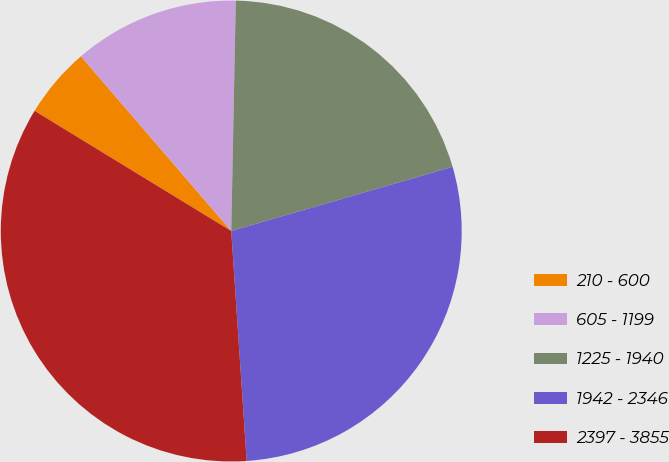<chart> <loc_0><loc_0><loc_500><loc_500><pie_chart><fcel>210 - 600<fcel>605 - 1199<fcel>1225 - 1940<fcel>1942 - 2346<fcel>2397 - 3855<nl><fcel>4.96%<fcel>11.62%<fcel>20.19%<fcel>28.42%<fcel>34.79%<nl></chart> 